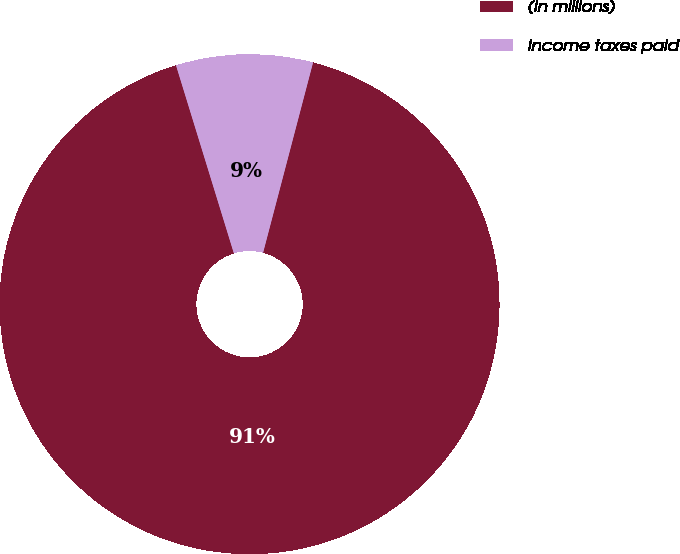Convert chart to OTSL. <chart><loc_0><loc_0><loc_500><loc_500><pie_chart><fcel>(In millions)<fcel>Income taxes paid<nl><fcel>91.16%<fcel>8.84%<nl></chart> 